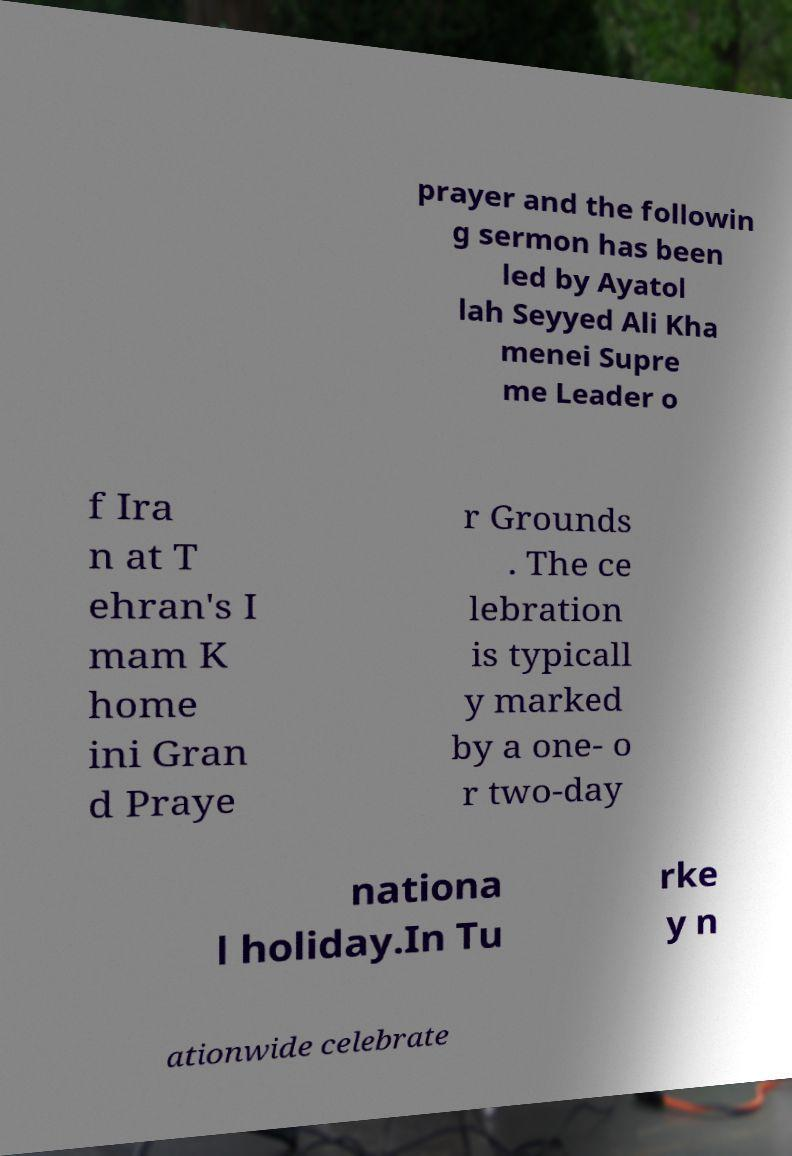Could you extract and type out the text from this image? prayer and the followin g sermon has been led by Ayatol lah Seyyed Ali Kha menei Supre me Leader o f Ira n at T ehran's I mam K home ini Gran d Praye r Grounds . The ce lebration is typicall y marked by a one- o r two-day nationa l holiday.In Tu rke y n ationwide celebrate 